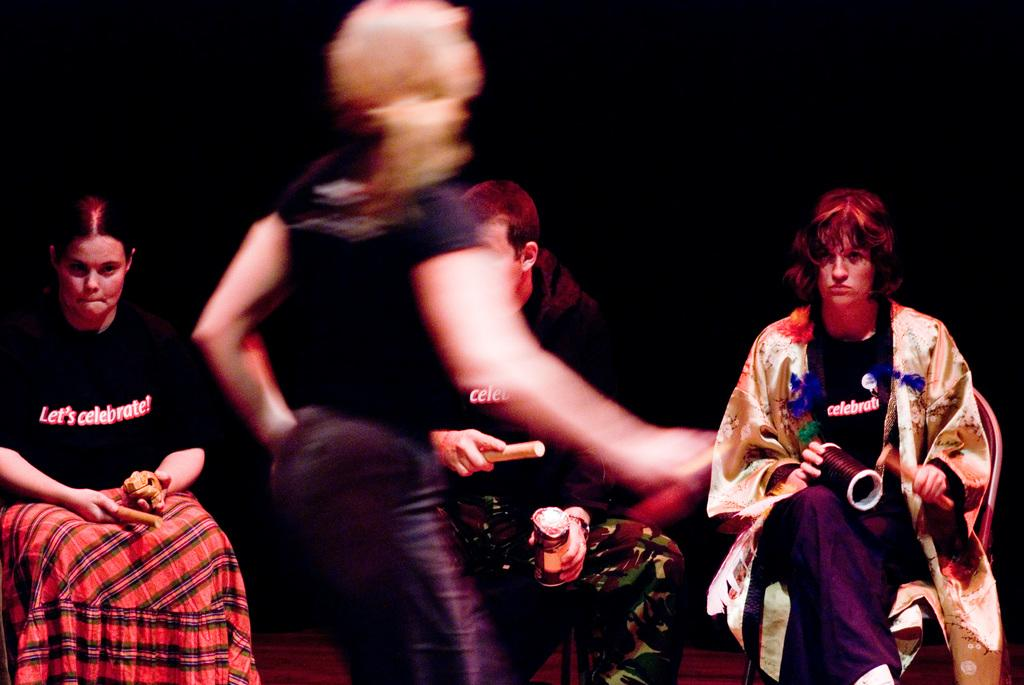What is the primary action of the person in the image? There is a person standing in the image. What are the other people in the image doing? The other people in the image are sitting. What are the people holding in their hands? The people are holding objects in their hands. What is the surface at the bottom of the image? There is a carpet at the bottom of the image. Is the person in the image riding a horse? There is no horse present in the image; the person is standing. Can you tell me if the person in the image is driving a vehicle? There is no vehicle present in the image, so it cannot be determined if the person is driving. 